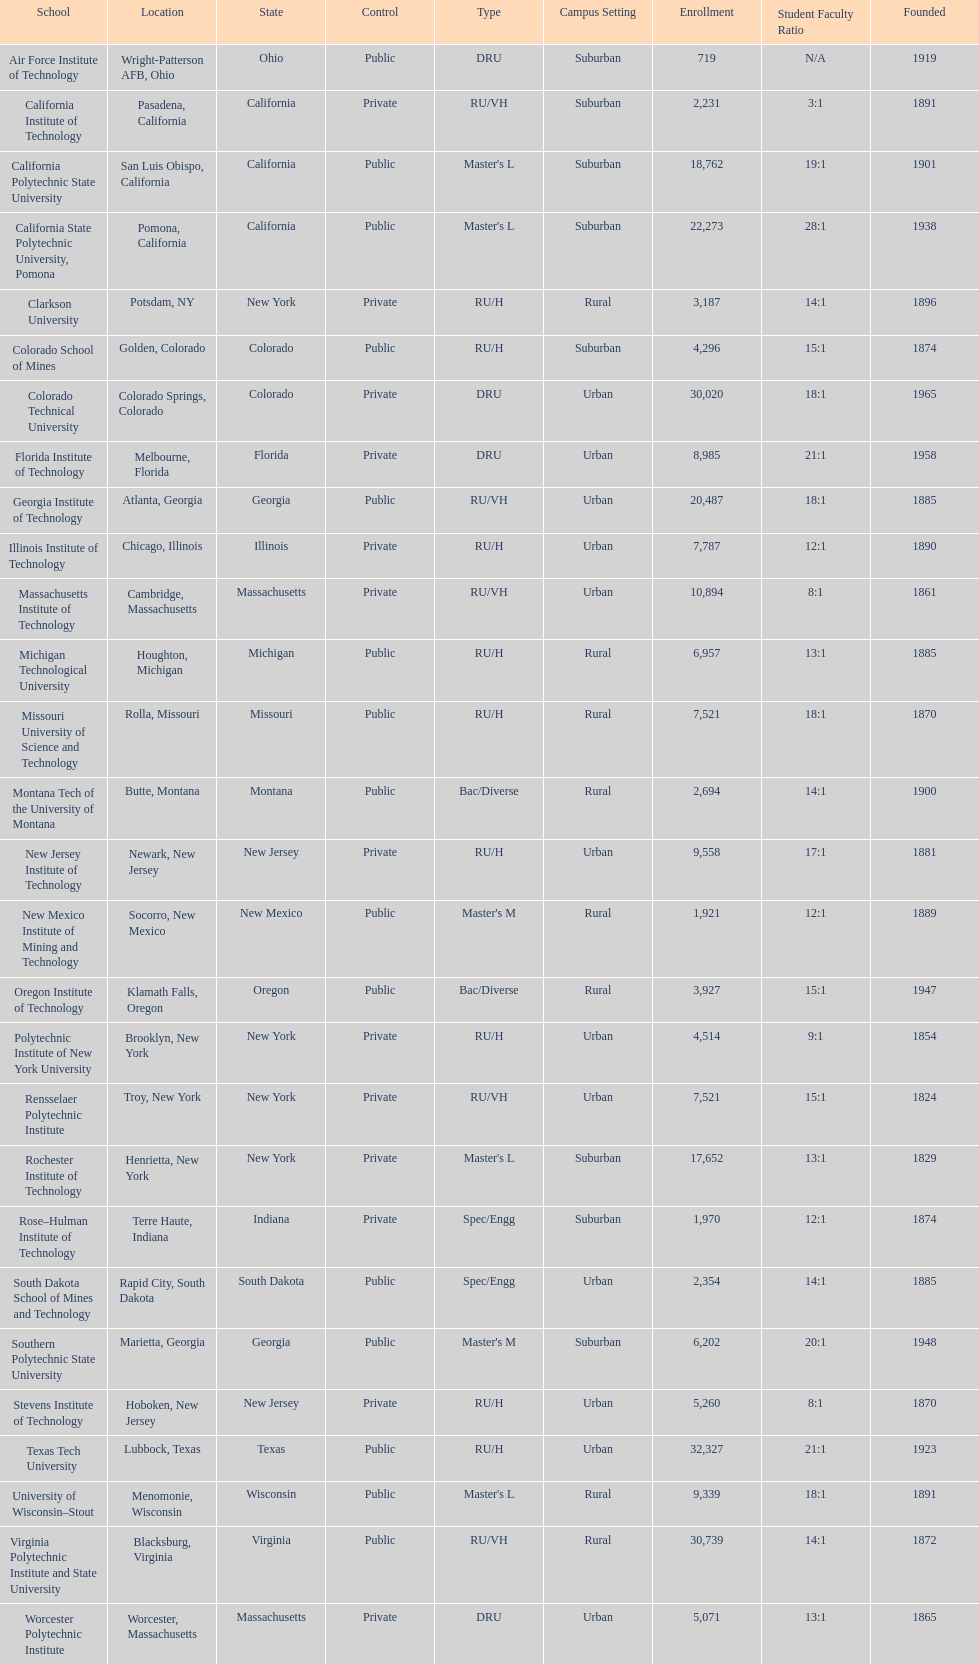What is the difference in enrollment between the top 2 schools listed in the table? 1512. 